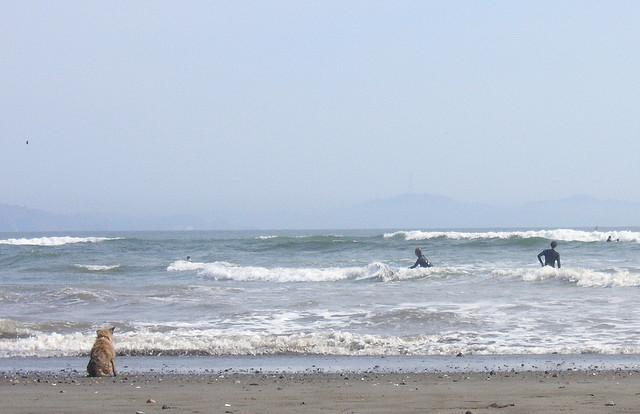Is the dog going to swim?
Be succinct. No. Are all the surfers in the water?
Answer briefly. Yes. Are there any building in the view?
Quick response, please. No. Is it high tide?
Answer briefly. No. Is the dog running?
Write a very short answer. No. Is the dog watching the surfers?
Quick response, please. Yes. What is the dog doing?
Concise answer only. Sitting. Does it look cold outside?
Answer briefly. No. What speed is the woman moving?
Quick response, please. Slow. What are these people doing?
Quick response, please. Surfing. Is the water calm?
Be succinct. No. Will the person get hurt if they fall?
Give a very brief answer. No. Is there an island in the sea?
Short answer required. Yes. Where is the dog?
Write a very short answer. Beach. 